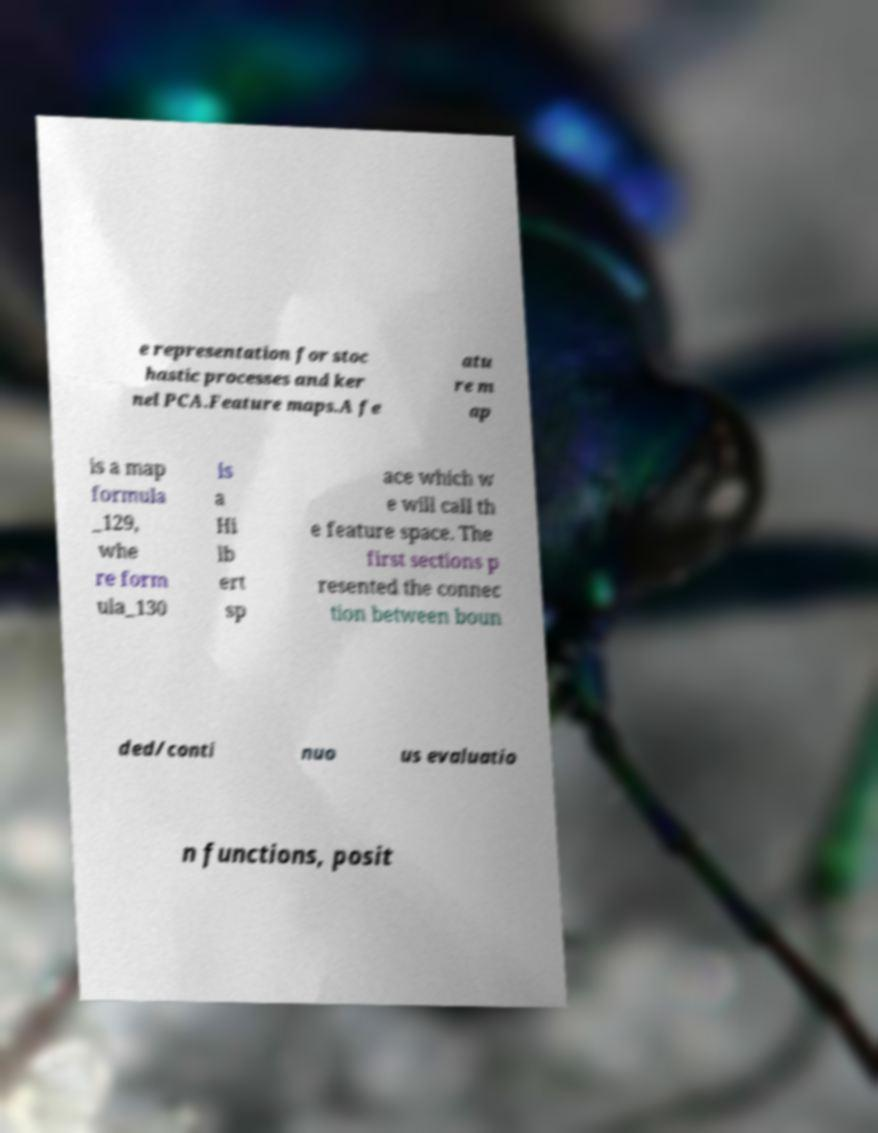What messages or text are displayed in this image? I need them in a readable, typed format. e representation for stoc hastic processes and ker nel PCA.Feature maps.A fe atu re m ap is a map formula _129, whe re form ula_130 is a Hi lb ert sp ace which w e will call th e feature space. The first sections p resented the connec tion between boun ded/conti nuo us evaluatio n functions, posit 